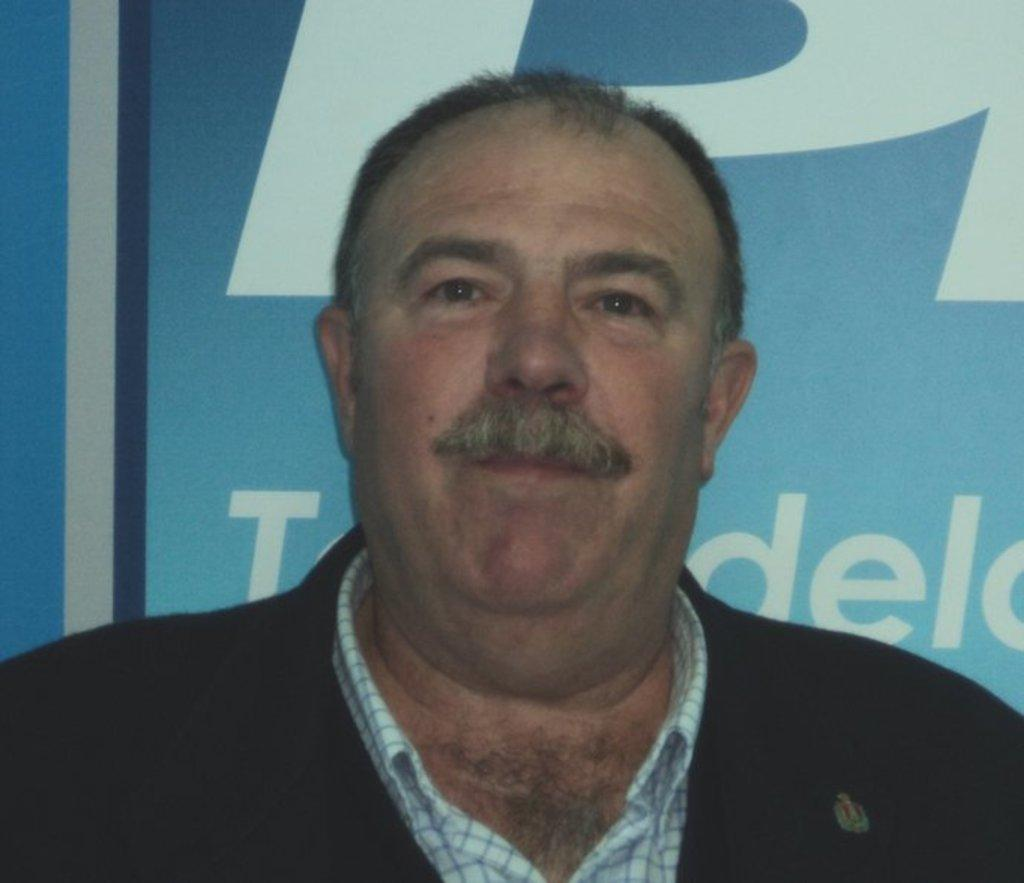What is the main subject of the image? There is a man in the image. Can you describe anything in the background of the image? There is a board in the background of the image. What type of garden can be seen in the image? There is no garden present in the image. What tool is the man using in the image? The image does not show the man using any tool, such as a hammer. 